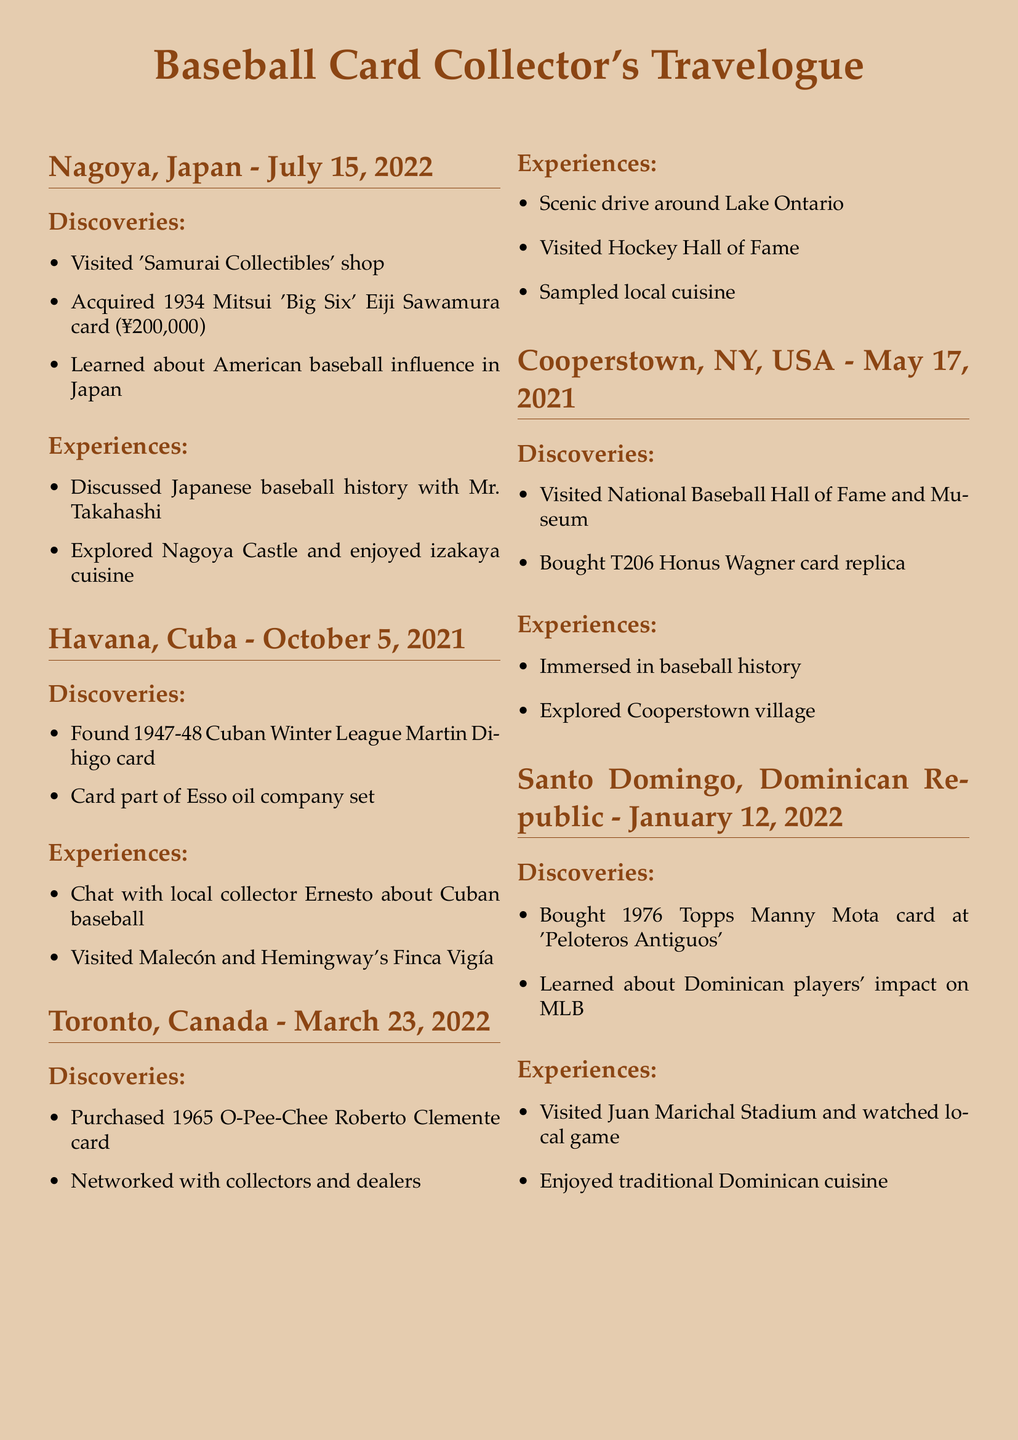What card was acquired in Nagoya? The document states that the 1934 Mitsui 'Big Six' Eiji Sawamura card was acquired in Nagoya.
Answer: 1934 Mitsui 'Big Six' Eiji Sawamura card Who did the traveler discuss Japanese baseball history with? The document mentions that the traveler discussed Japanese baseball history with Mr. Takahashi.
Answer: Mr. Takahashi What significant location was visited in Havana? According to the document, the traveler visited Malecón and Hemingway's Finca Vigía in Havana.
Answer: Malecón and Hemingway's Finca Vigía What type of card was purchased in Toronto? The document describes that the 1965 O-Pee-Chee Roberto Clemente card was purchased in Toronto.
Answer: 1965 O-Pee-Chee Roberto Clemente card When did the traveler visit Cooperstown? The document specifies that the traveler visited Cooperstown on May 17, 2021.
Answer: May 17, 2021 What was learned in the Dominican Republic? The document indicates that the traveler learned about Dominican players' impact on MLB in the Dominican Republic.
Answer: Dominican players' impact on MLB What was a notable experience in Toronto? The document states that the traveler had a scenic drive around Lake Ontario in Toronto.
Answer: Scenic drive around Lake Ontario Which card was part of an Esso oil company set? The document mentions that the 1947-48 Cuban Winter League Martin Dihigo card was part of the Esso oil company set.
Answer: 1947-48 Cuban Winter League Martin Dihigo card What sport-related place did the traveler visit in Toronto? The document notes that the traveler visited the Hockey Hall of Fame in Toronto.
Answer: Hockey Hall of Fame 